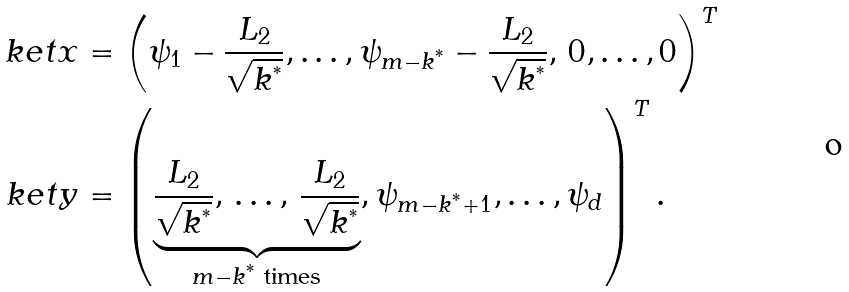<formula> <loc_0><loc_0><loc_500><loc_500>\ k e t { x } & = \left ( \psi _ { 1 } - \frac { L _ { 2 } } { \sqrt { k ^ { ^ { * } } } } , \dots , \psi _ { m - k ^ { ^ { * } } } - \frac { L _ { 2 } } { \sqrt { k ^ { ^ { * } } } } , \, 0 , \dots , 0 \right ) ^ { T } \\ \ k e t { y } & = \left ( \underbrace { \frac { L _ { 2 } } { \sqrt { k ^ { ^ { * } } } } , \, \dots , \, \frac { L _ { 2 } } { \sqrt { k ^ { ^ { * } } } } } _ { m - k ^ { ^ { * } } \text { times} } , \psi _ { m - k ^ { ^ { * } } + 1 } , \dots , \psi _ { d } \right ) ^ { T } .</formula> 